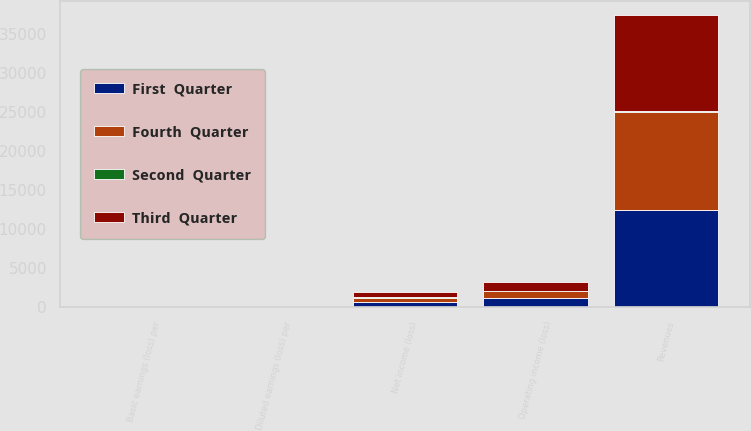Convert chart to OTSL. <chart><loc_0><loc_0><loc_500><loc_500><stacked_bar_chart><ecel><fcel>Revenues<fcel>Operating income (loss)<fcel>Net income (loss)<fcel>Basic earnings (loss) per<fcel>Diluted earnings (loss) per<nl><fcel>Third  Quarter<fcel>12279<fcel>1144<fcel>692<fcel>2.45<fcel>2.42<nl><fcel>First  Quarter<fcel>12453<fcel>1137<fcel>691<fcel>2.47<fcel>2.44<nl><fcel>Fourth  Quarter<fcel>12654<fcel>864<fcel>507<fcel>1.86<fcel>1.84<nl><fcel>Second  Quarter<fcel>70<fcel>68<fcel>70<fcel>0.26<fcel>0.26<nl></chart> 